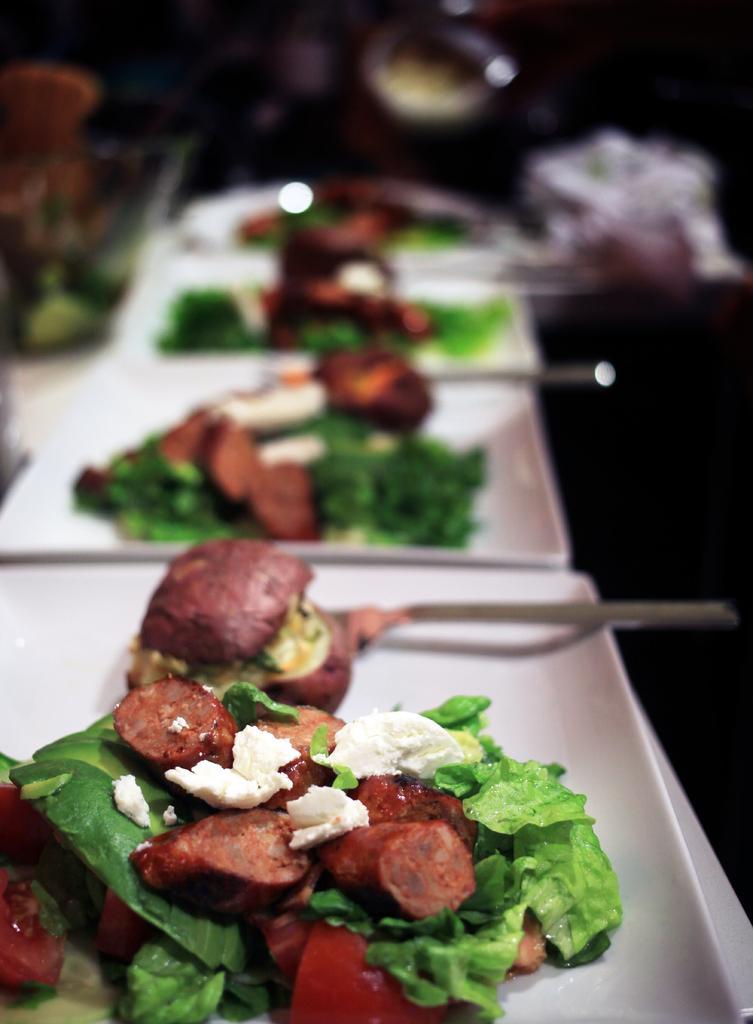Describe this image in one or two sentences. Here we can see a food items and spoons in the plates on a platform. In the background the image is blur but we can see some objects. 